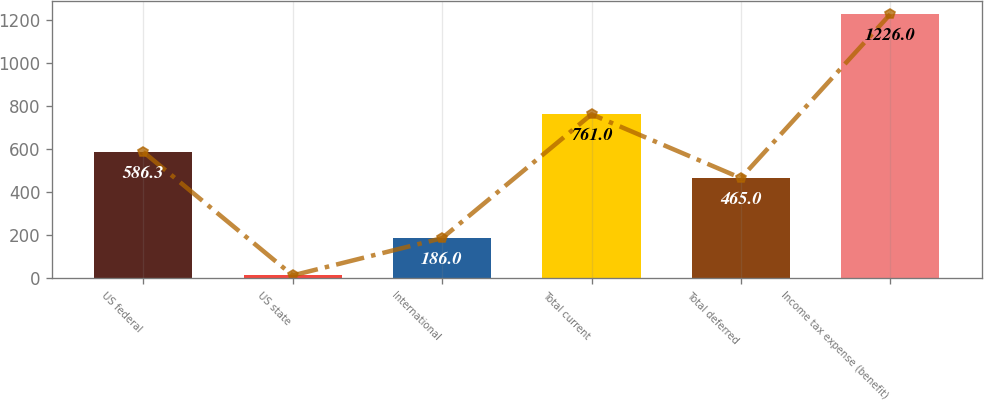<chart> <loc_0><loc_0><loc_500><loc_500><bar_chart><fcel>US federal<fcel>US state<fcel>International<fcel>Total current<fcel>Total deferred<fcel>Income tax expense (benefit)<nl><fcel>586.3<fcel>13<fcel>186<fcel>761<fcel>465<fcel>1226<nl></chart> 